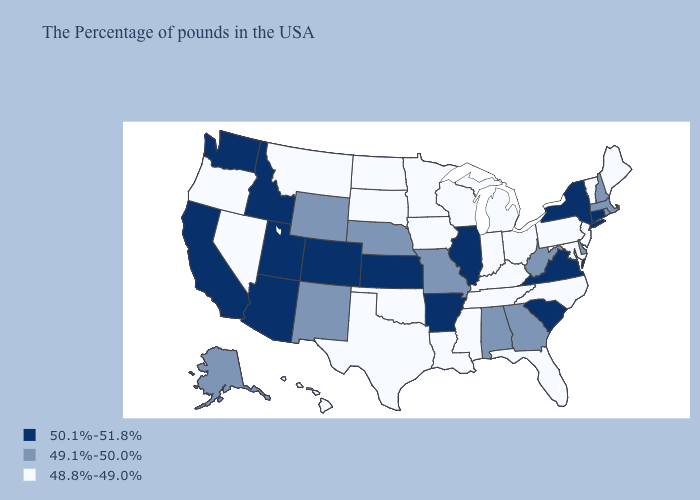Which states hav the highest value in the MidWest?
Quick response, please. Illinois, Kansas. What is the highest value in the South ?
Keep it brief. 50.1%-51.8%. How many symbols are there in the legend?
Give a very brief answer. 3. Does the first symbol in the legend represent the smallest category?
Write a very short answer. No. What is the value of New Mexico?
Concise answer only. 49.1%-50.0%. Which states hav the highest value in the South?
Answer briefly. Virginia, South Carolina, Arkansas. Is the legend a continuous bar?
Answer briefly. No. What is the value of South Carolina?
Quick response, please. 50.1%-51.8%. Among the states that border Indiana , does Illinois have the highest value?
Short answer required. Yes. Name the states that have a value in the range 48.8%-49.0%?
Answer briefly. Maine, Vermont, New Jersey, Maryland, Pennsylvania, North Carolina, Ohio, Florida, Michigan, Kentucky, Indiana, Tennessee, Wisconsin, Mississippi, Louisiana, Minnesota, Iowa, Oklahoma, Texas, South Dakota, North Dakota, Montana, Nevada, Oregon, Hawaii. What is the highest value in states that border Utah?
Give a very brief answer. 50.1%-51.8%. Name the states that have a value in the range 48.8%-49.0%?
Give a very brief answer. Maine, Vermont, New Jersey, Maryland, Pennsylvania, North Carolina, Ohio, Florida, Michigan, Kentucky, Indiana, Tennessee, Wisconsin, Mississippi, Louisiana, Minnesota, Iowa, Oklahoma, Texas, South Dakota, North Dakota, Montana, Nevada, Oregon, Hawaii. Does New Jersey have the lowest value in the Northeast?
Short answer required. Yes. What is the value of Utah?
Answer briefly. 50.1%-51.8%. 